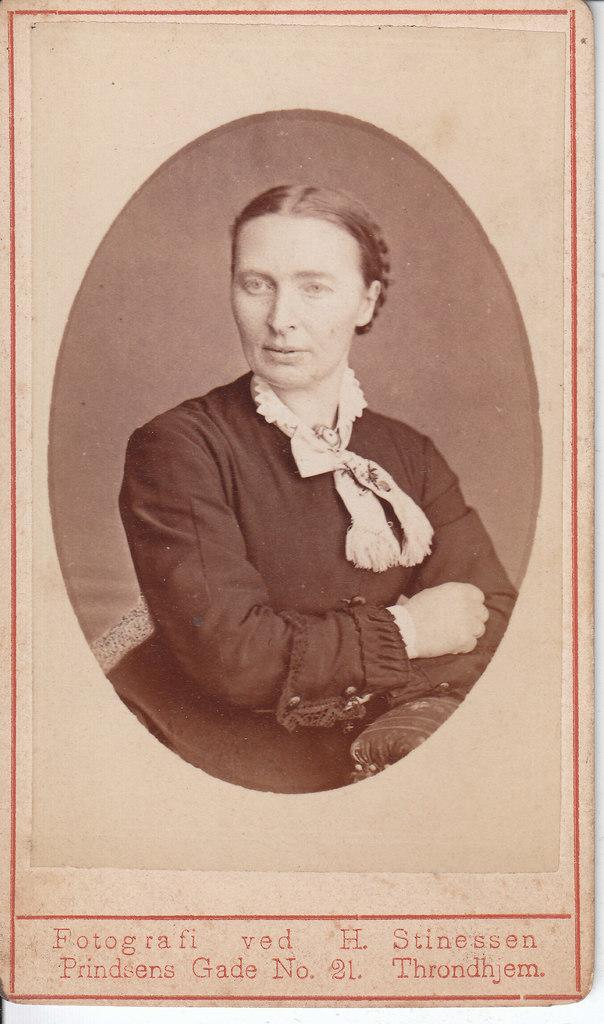What is the main subject of the image? There is a depiction of a lady in the center of the image. Is there any text present in the image? Yes, there is text at the bottom of the image. What type of texture does the donkey have in the image? There is no donkey present in the image, so it is not possible to determine its texture. 